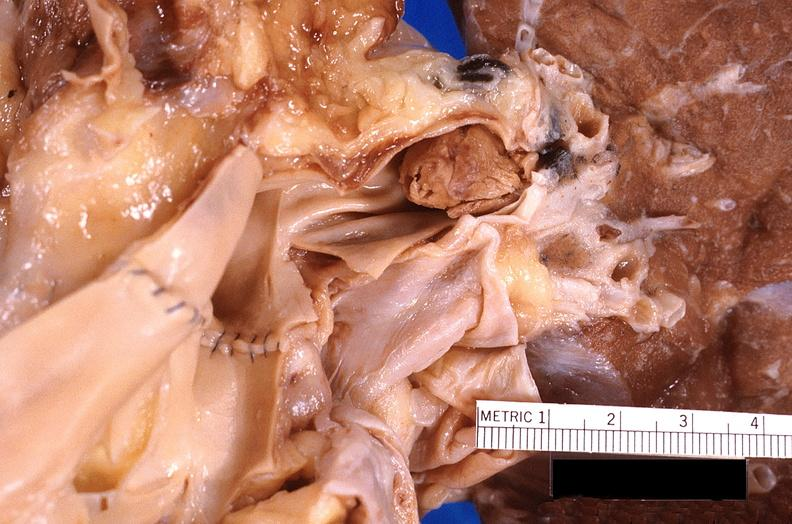what does this image show?
Answer the question using a single word or phrase. Thromboembolus from leg veins in pulmonary artery 